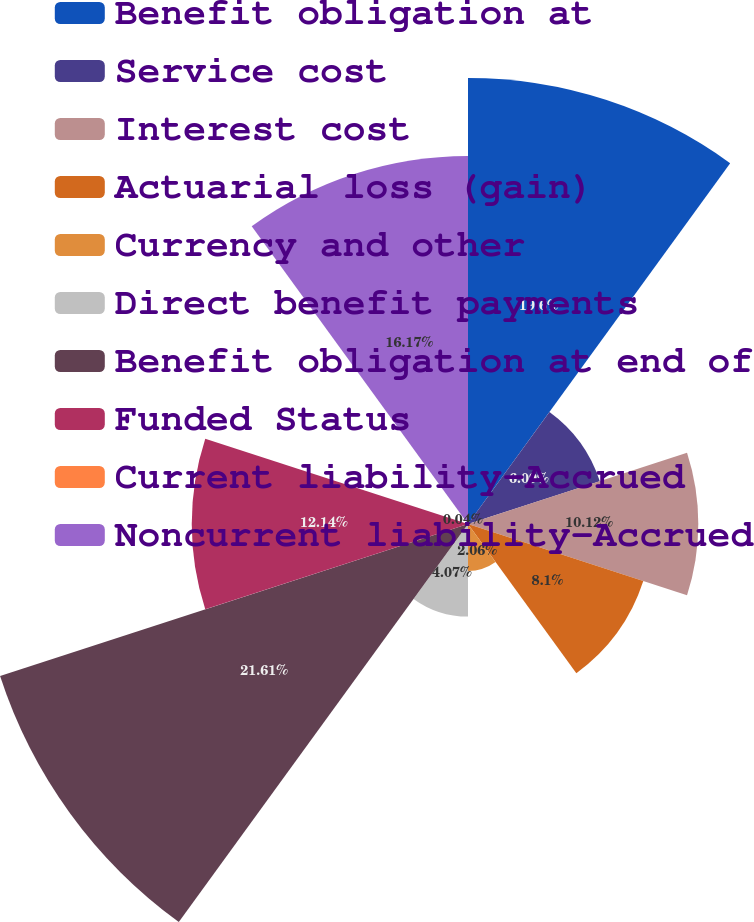<chart> <loc_0><loc_0><loc_500><loc_500><pie_chart><fcel>Benefit obligation at<fcel>Service cost<fcel>Interest cost<fcel>Actuarial loss (gain)<fcel>Currency and other<fcel>Direct benefit payments<fcel>Benefit obligation at end of<fcel>Funded Status<fcel>Current liability-Accrued<fcel>Noncurrent liability-Accrued<nl><fcel>19.6%<fcel>6.09%<fcel>10.12%<fcel>8.1%<fcel>2.06%<fcel>4.07%<fcel>21.62%<fcel>12.14%<fcel>0.04%<fcel>16.17%<nl></chart> 